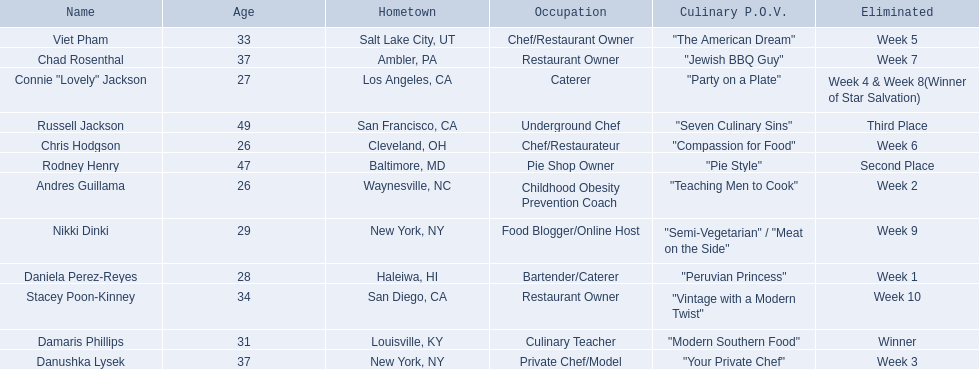Who are the  food network stars? Damaris Phillips, Rodney Henry, Russell Jackson, Stacey Poon-Kinney, Nikki Dinki, Chad Rosenthal, Chris Hodgson, Viet Pham, Connie "Lovely" Jackson, Danushka Lysek, Andres Guillama, Daniela Perez-Reyes. When did nikki dinki get eliminated? Week 9. When did viet pham get eliminated? Week 5. Which week came first? Week 5. Who was it that was eliminated week 5? Viet Pham. 